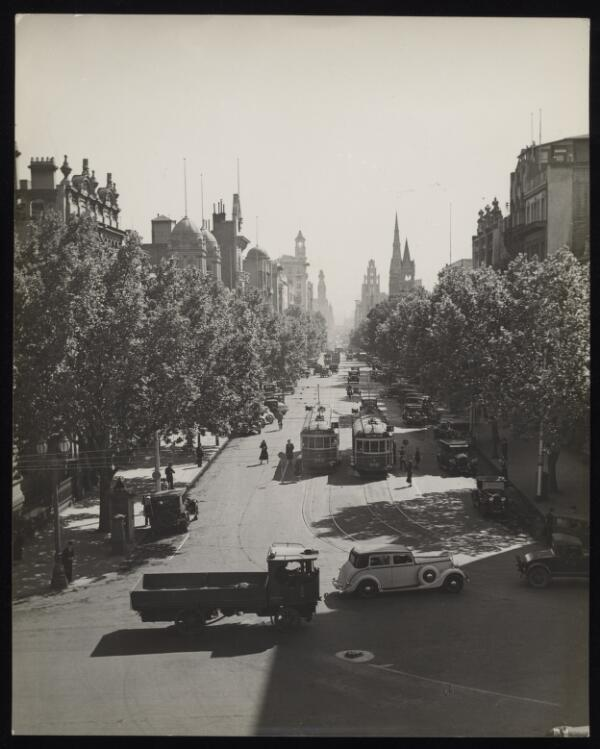Please describe the contents of this image in 5 or 6 sentences so that a person searching for it using text will be able to find it and your generated summary will provide them with an accurate description of the image. Only describe content present in the image. The image is a black and white photograph taken in the early 20th century. It shows a wide street with a number of trams and cars on it. The street is lined with trees and there are buildings on either side. The image is a good example of the urban landscape of the time. 